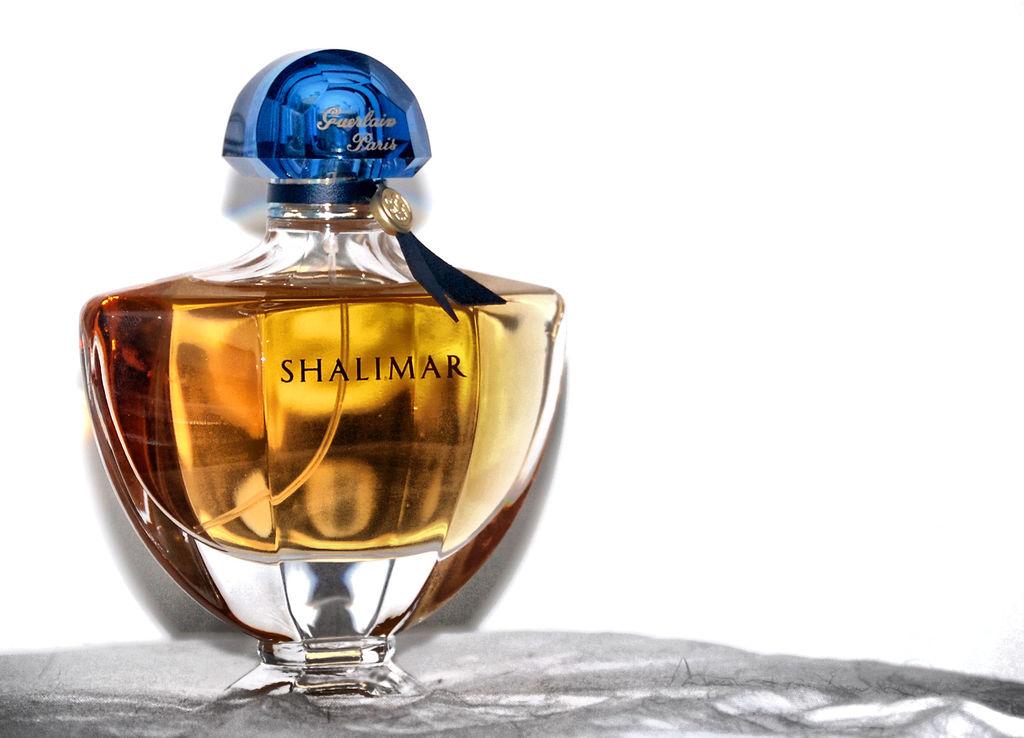Who is the maker of the perfume shalimar?
Provide a succinct answer. Shalimar. Where was this made?
Provide a succinct answer. Paris. 